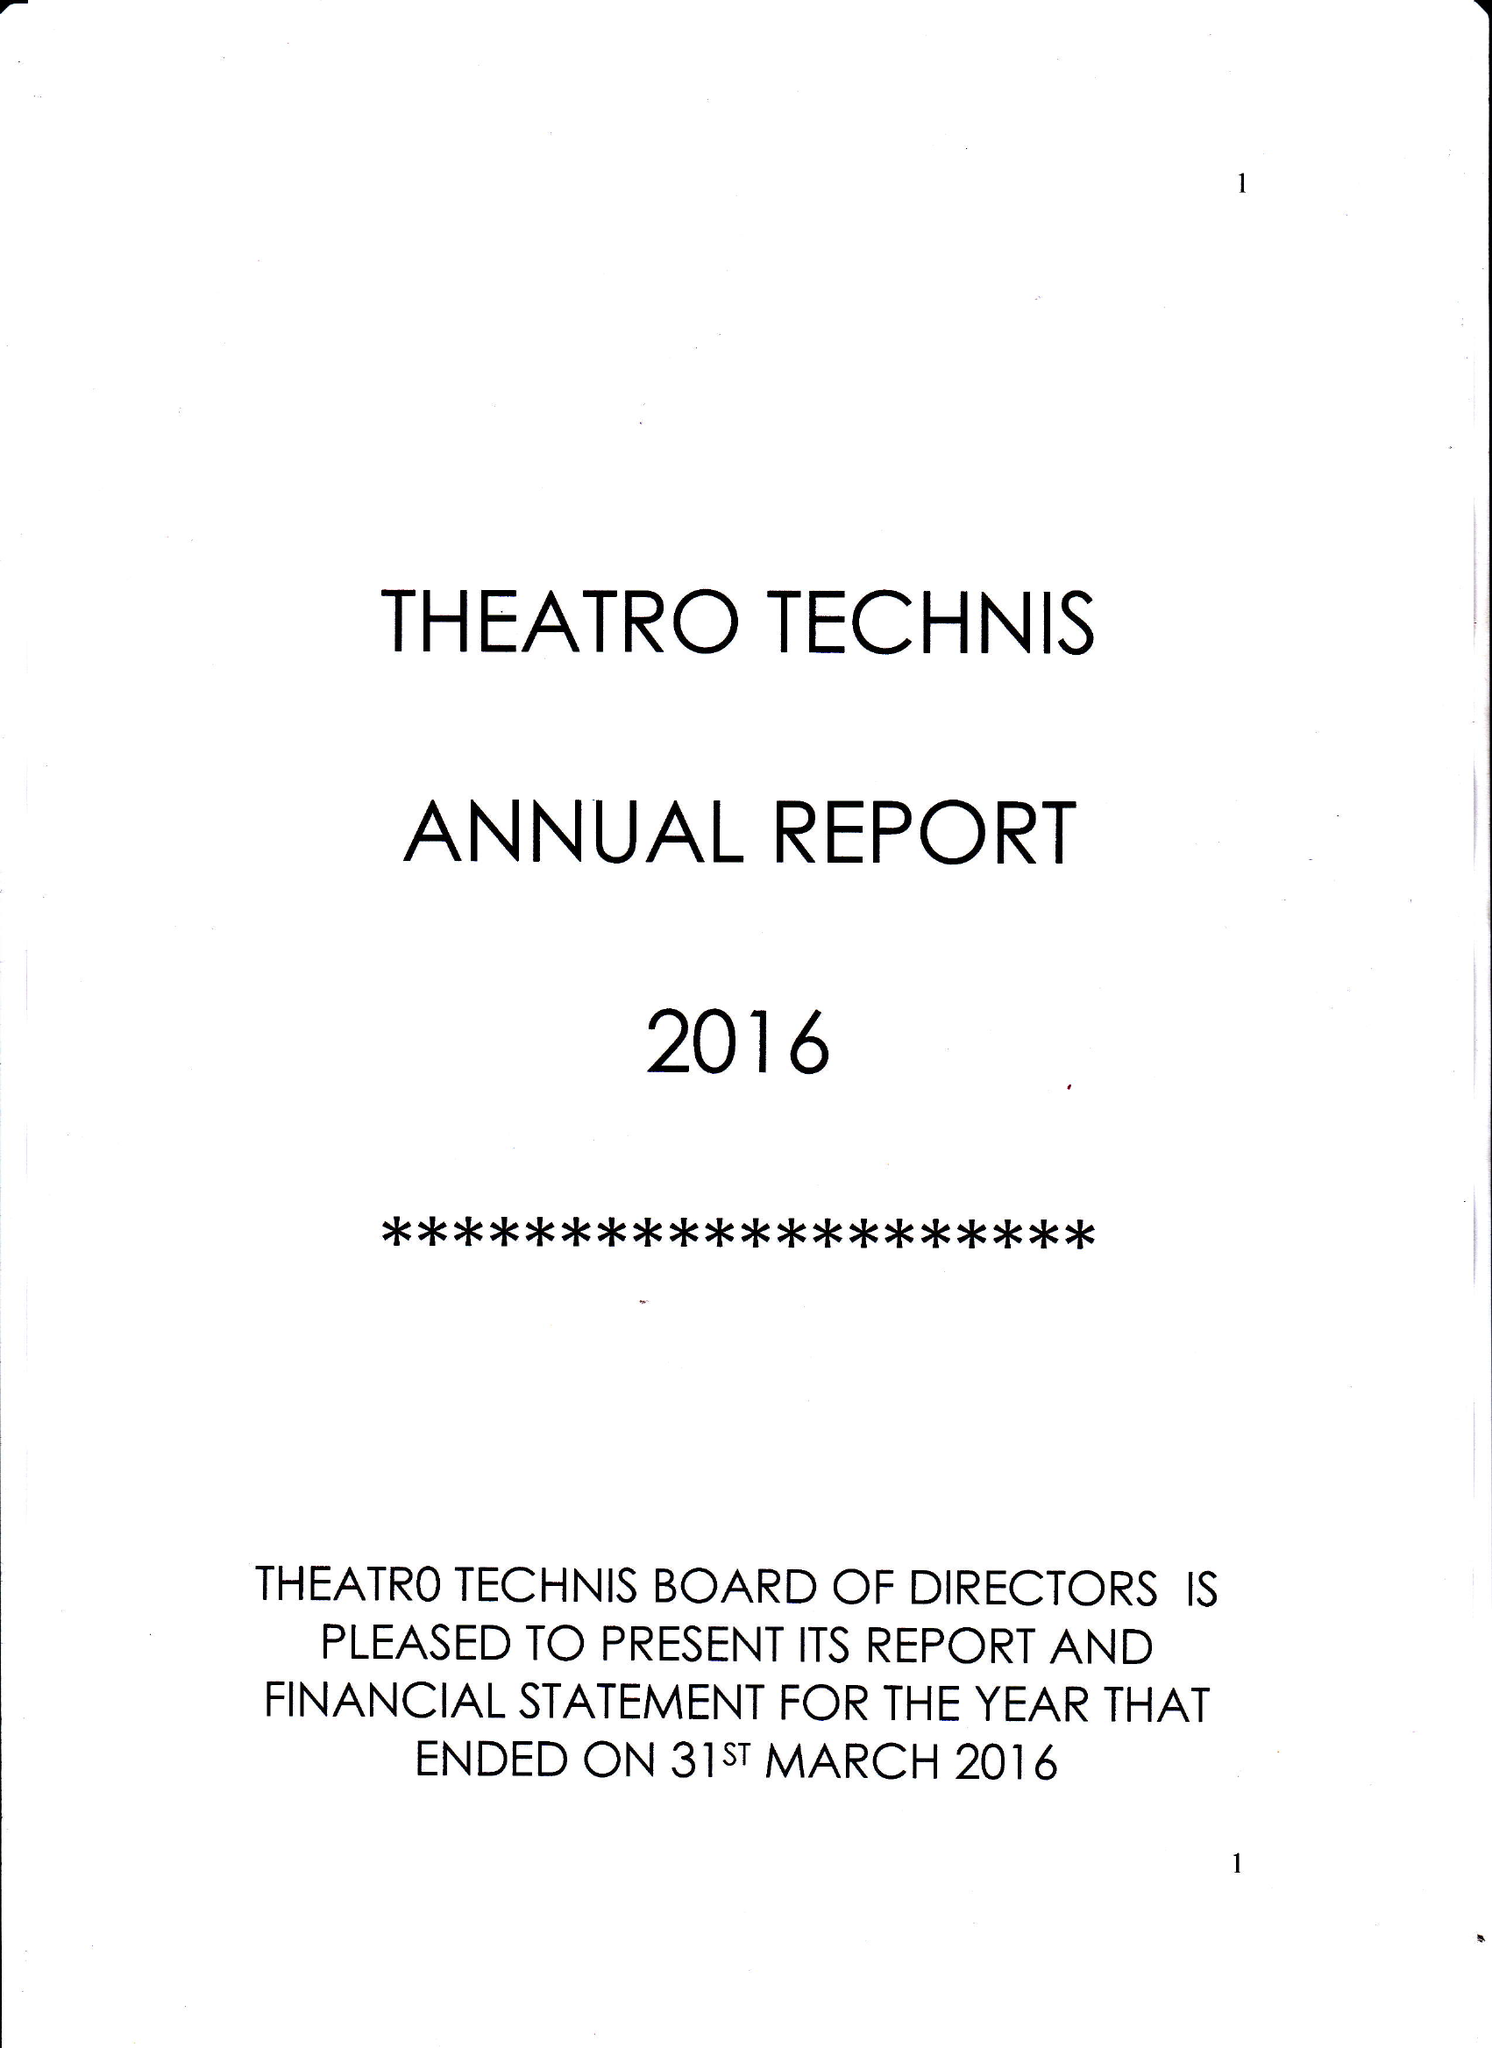What is the value for the address__street_line?
Answer the question using a single word or phrase. 26 CROWNDALE ROAD 